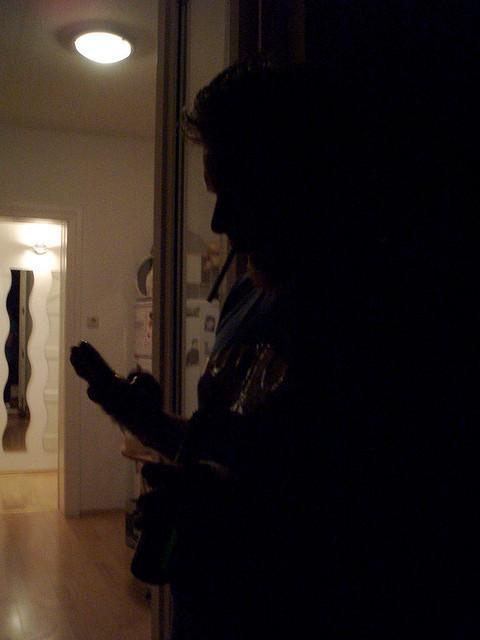How many refrigerators are in the photo?
Give a very brief answer. 1. 